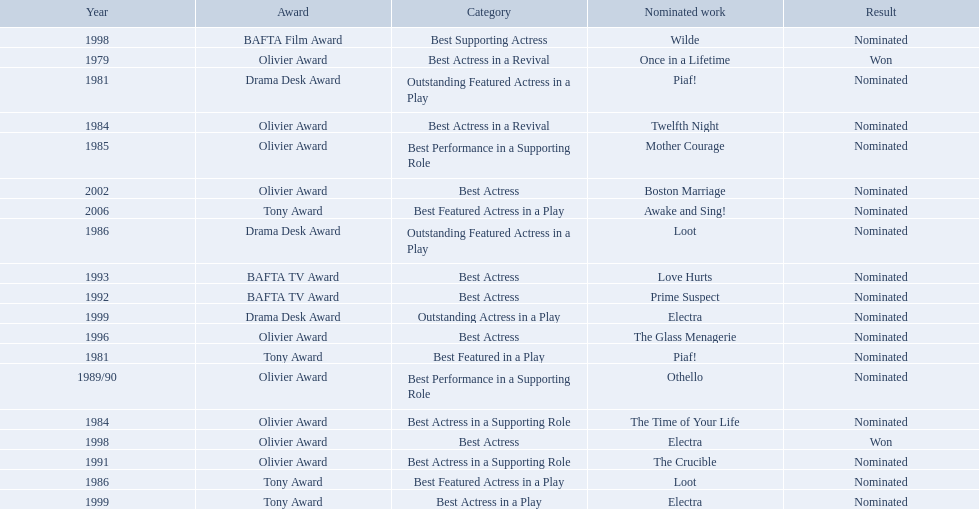What were all of the nominated works with zoe wanamaker? Once in a Lifetime, Piaf!, Piaf!, Twelfth Night, The Time of Your Life, Mother Courage, Loot, Loot, Othello, The Crucible, Prime Suspect, Love Hurts, The Glass Menagerie, Wilde, Electra, Electra, Electra, Boston Marriage, Awake and Sing!. And in which years were these nominations? 1979, 1981, 1981, 1984, 1984, 1985, 1986, 1986, 1989/90, 1991, 1992, 1993, 1996, 1998, 1998, 1999, 1999, 2002, 2006. Which categories was she nominated for in 1984? Best Actress in a Revival. And for which work was this nomination? Twelfth Night. 